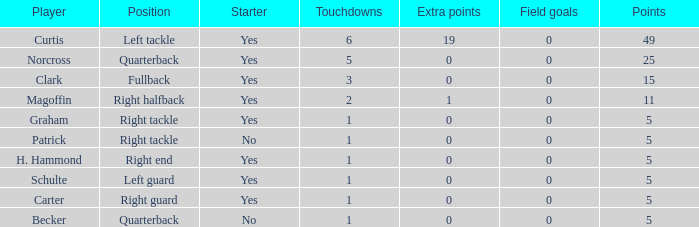Name the most touchdowns for norcross 5.0. 